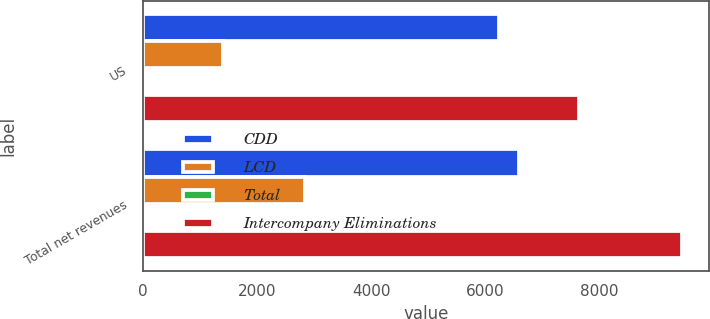<chart> <loc_0><loc_0><loc_500><loc_500><stacked_bar_chart><ecel><fcel>US<fcel>Total net revenues<nl><fcel>CDD<fcel>6246.1<fcel>6593.9<nl><fcel>LCD<fcel>1395.2<fcel>2844.1<nl><fcel>Total<fcel>0.8<fcel>0.8<nl><fcel>Intercompany Eliminations<fcel>7640.5<fcel>9437.2<nl></chart> 